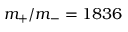Convert formula to latex. <formula><loc_0><loc_0><loc_500><loc_500>m _ { + } / m _ { - } = 1 8 3 6</formula> 